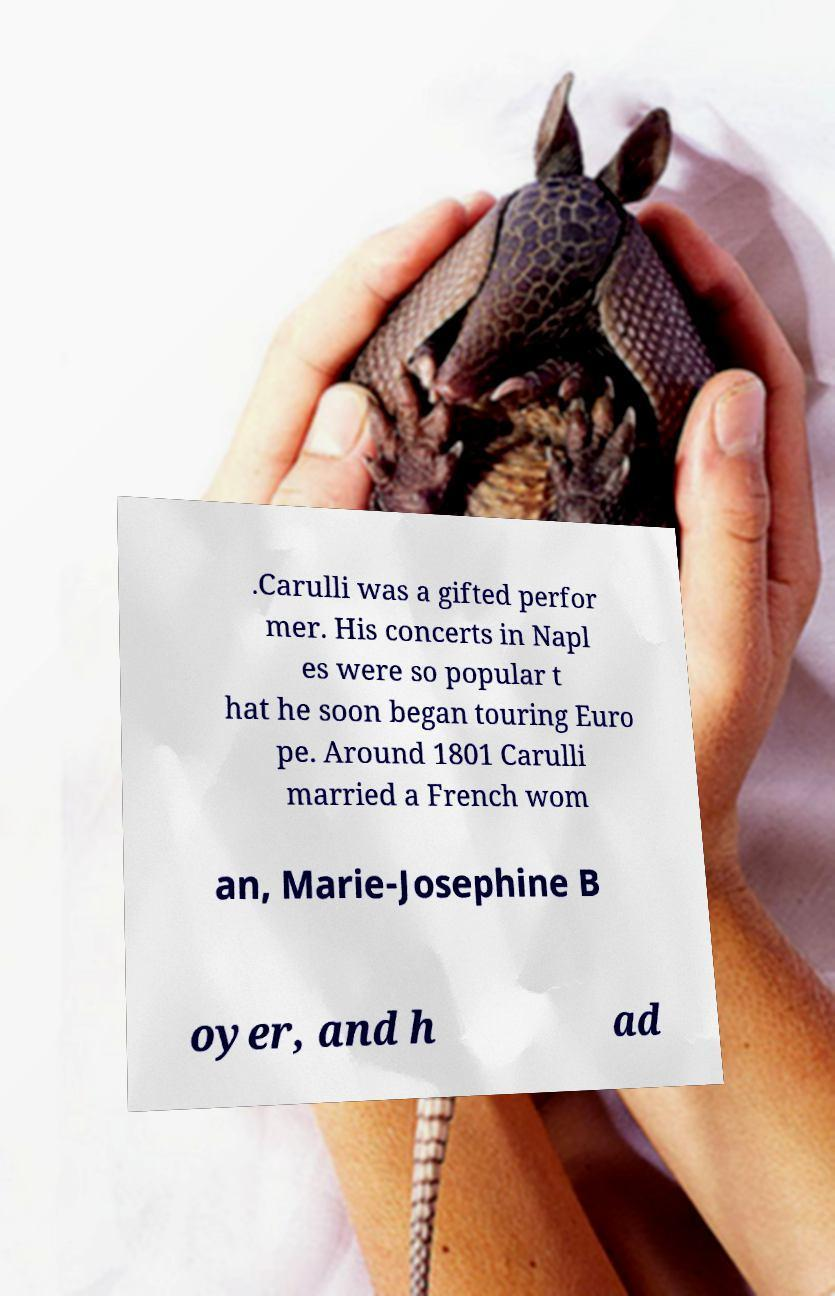There's text embedded in this image that I need extracted. Can you transcribe it verbatim? .Carulli was a gifted perfor mer. His concerts in Napl es were so popular t hat he soon began touring Euro pe. Around 1801 Carulli married a French wom an, Marie-Josephine B oyer, and h ad 